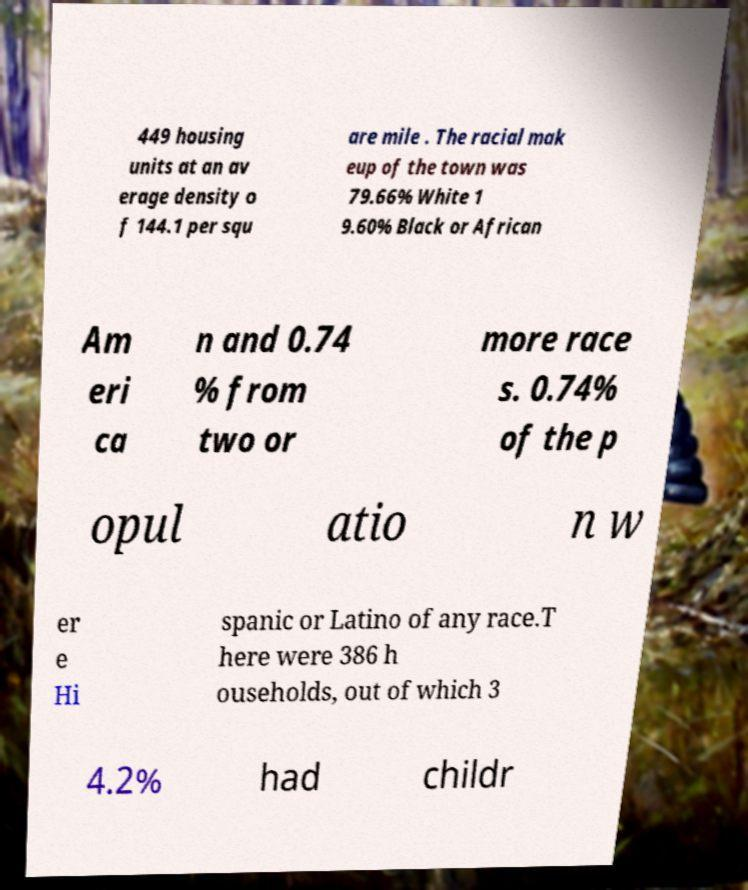Can you accurately transcribe the text from the provided image for me? 449 housing units at an av erage density o f 144.1 per squ are mile . The racial mak eup of the town was 79.66% White 1 9.60% Black or African Am eri ca n and 0.74 % from two or more race s. 0.74% of the p opul atio n w er e Hi spanic or Latino of any race.T here were 386 h ouseholds, out of which 3 4.2% had childr 